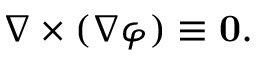Convert formula to latex. <formula><loc_0><loc_0><loc_500><loc_500>\nabla \times ( \nabla \varphi ) \equiv 0 .</formula> 